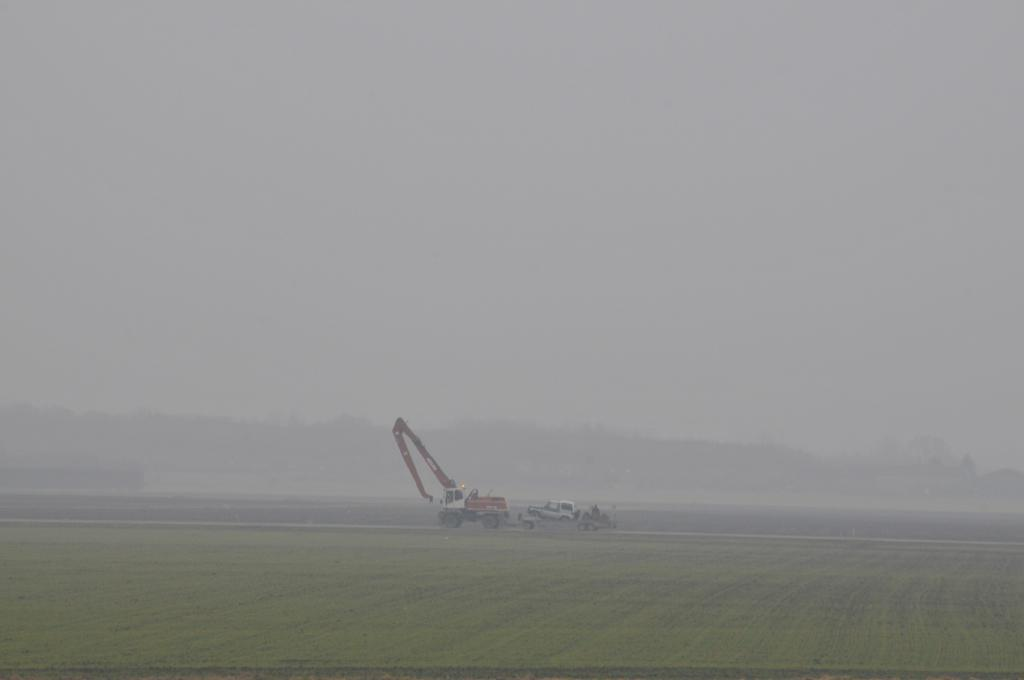What type of vegetation is present on the ground in the front of the image? There is grass on the ground in the front of the image. What can be seen in the center of the image? There are vehicles in the center of the image. What is visible in the background of the image? There are trees and a cloudy sky in the background of the image. Can you describe the smoke visible in the image? Yes, there is smoke visible in the image. What type of store is located in the cellar of the building in the image? There is no store or cellar present in the image; it features grass, vehicles, trees, a cloudy sky, and smoke. What is the tendency of the smoke in the image? The question about the "tendency" of the smoke is unclear and cannot be answered definitively based on the provided facts. 